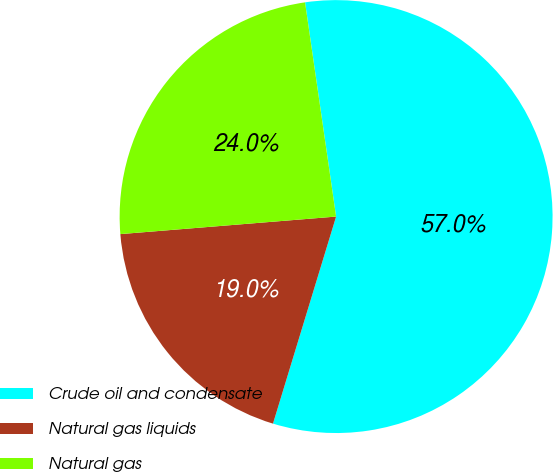Convert chart. <chart><loc_0><loc_0><loc_500><loc_500><pie_chart><fcel>Crude oil and condensate<fcel>Natural gas liquids<fcel>Natural gas<nl><fcel>57.0%<fcel>19.0%<fcel>24.0%<nl></chart> 